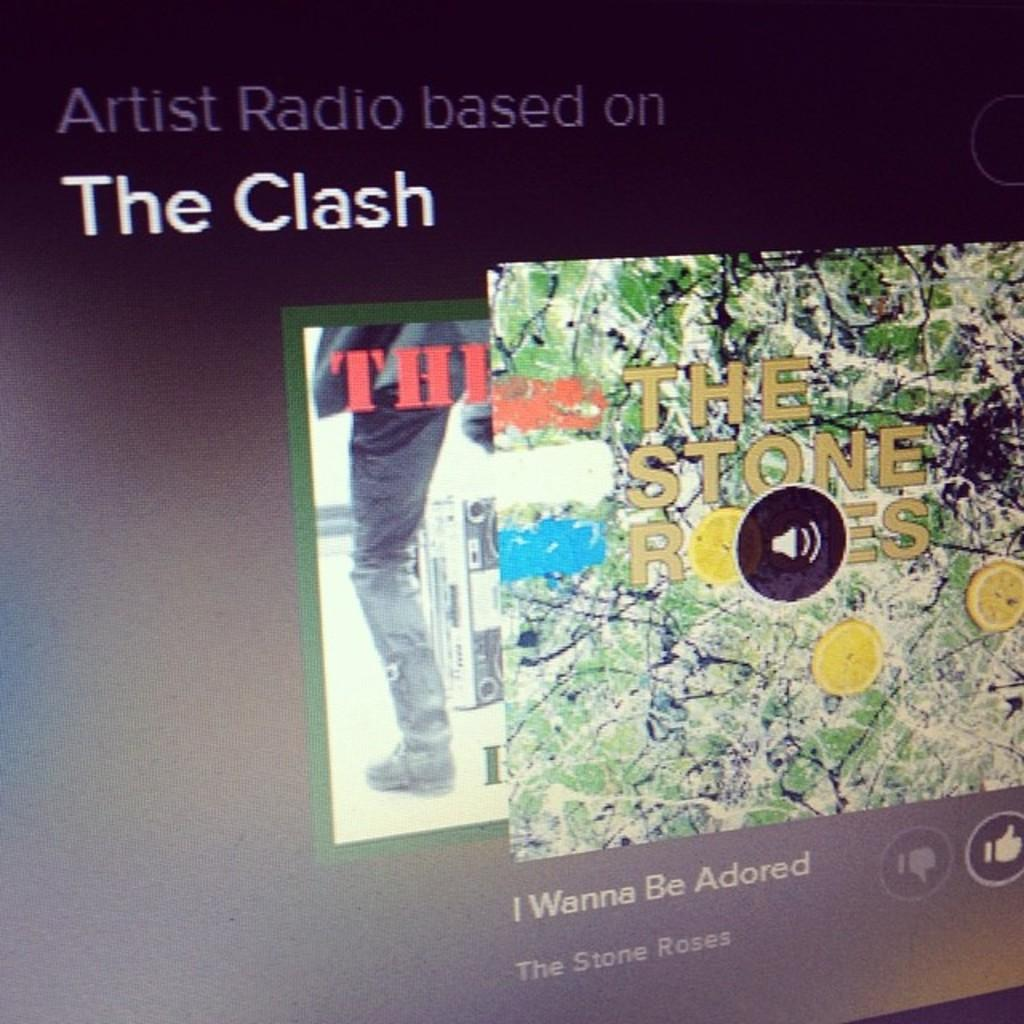<image>
Describe the image concisely. A screen shot of Artist Radio based on the Clash. 